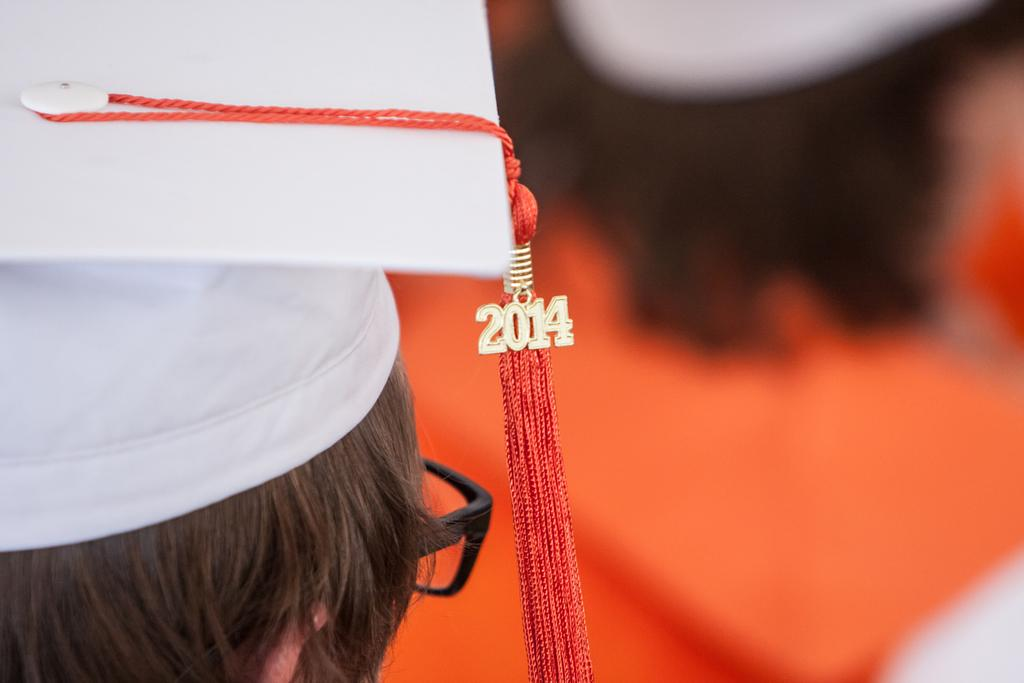What is the person in the image wearing on their head? The person in the image is wearing a white cap. What is unique about the cap? The cap has a thread attached to it. What is hanging from the thread? There is a number locket on the thread. Can you describe the setting of the image? There is another person in the background of the image. What type of crown is the person wearing in the image? There is no crown present in the image; the person is wearing a white cap with a thread and a number locket. 